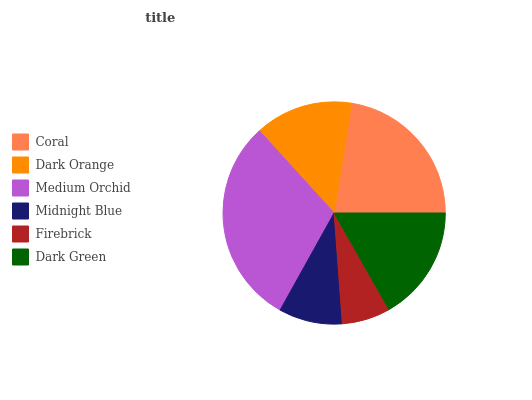Is Firebrick the minimum?
Answer yes or no. Yes. Is Medium Orchid the maximum?
Answer yes or no. Yes. Is Dark Orange the minimum?
Answer yes or no. No. Is Dark Orange the maximum?
Answer yes or no. No. Is Coral greater than Dark Orange?
Answer yes or no. Yes. Is Dark Orange less than Coral?
Answer yes or no. Yes. Is Dark Orange greater than Coral?
Answer yes or no. No. Is Coral less than Dark Orange?
Answer yes or no. No. Is Dark Green the high median?
Answer yes or no. Yes. Is Dark Orange the low median?
Answer yes or no. Yes. Is Medium Orchid the high median?
Answer yes or no. No. Is Midnight Blue the low median?
Answer yes or no. No. 